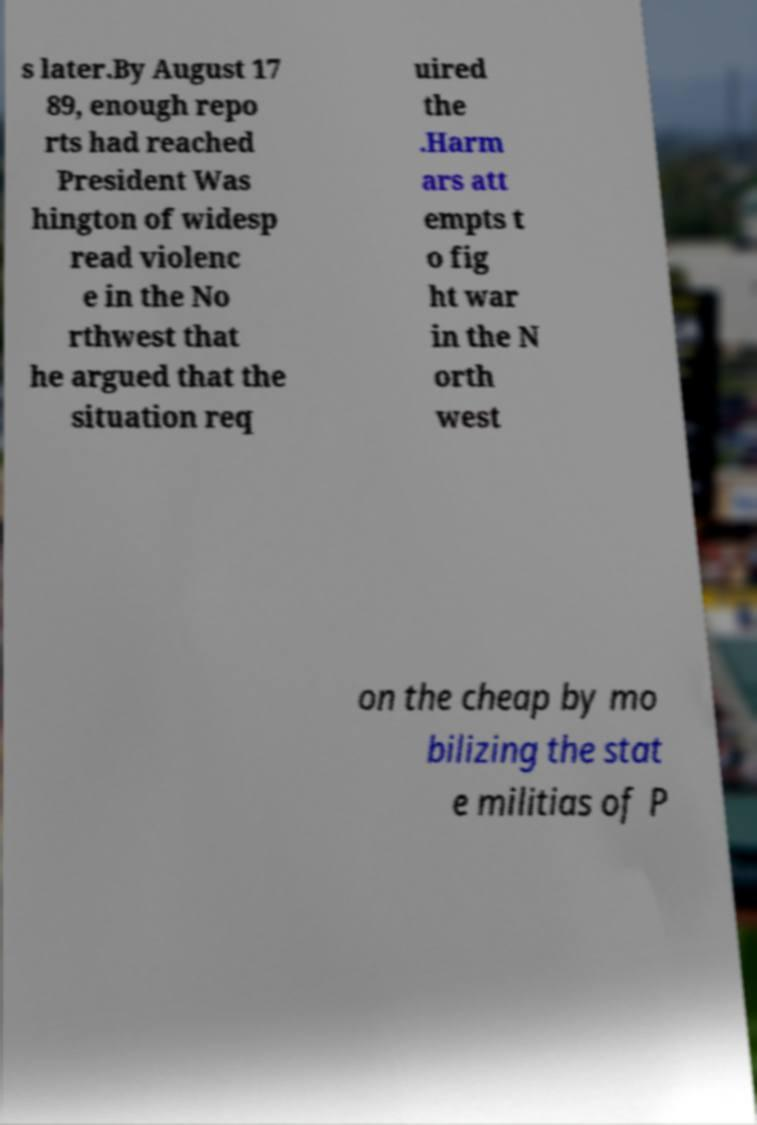Could you extract and type out the text from this image? s later.By August 17 89, enough repo rts had reached President Was hington of widesp read violenc e in the No rthwest that he argued that the situation req uired the .Harm ars att empts t o fig ht war in the N orth west on the cheap by mo bilizing the stat e militias of P 